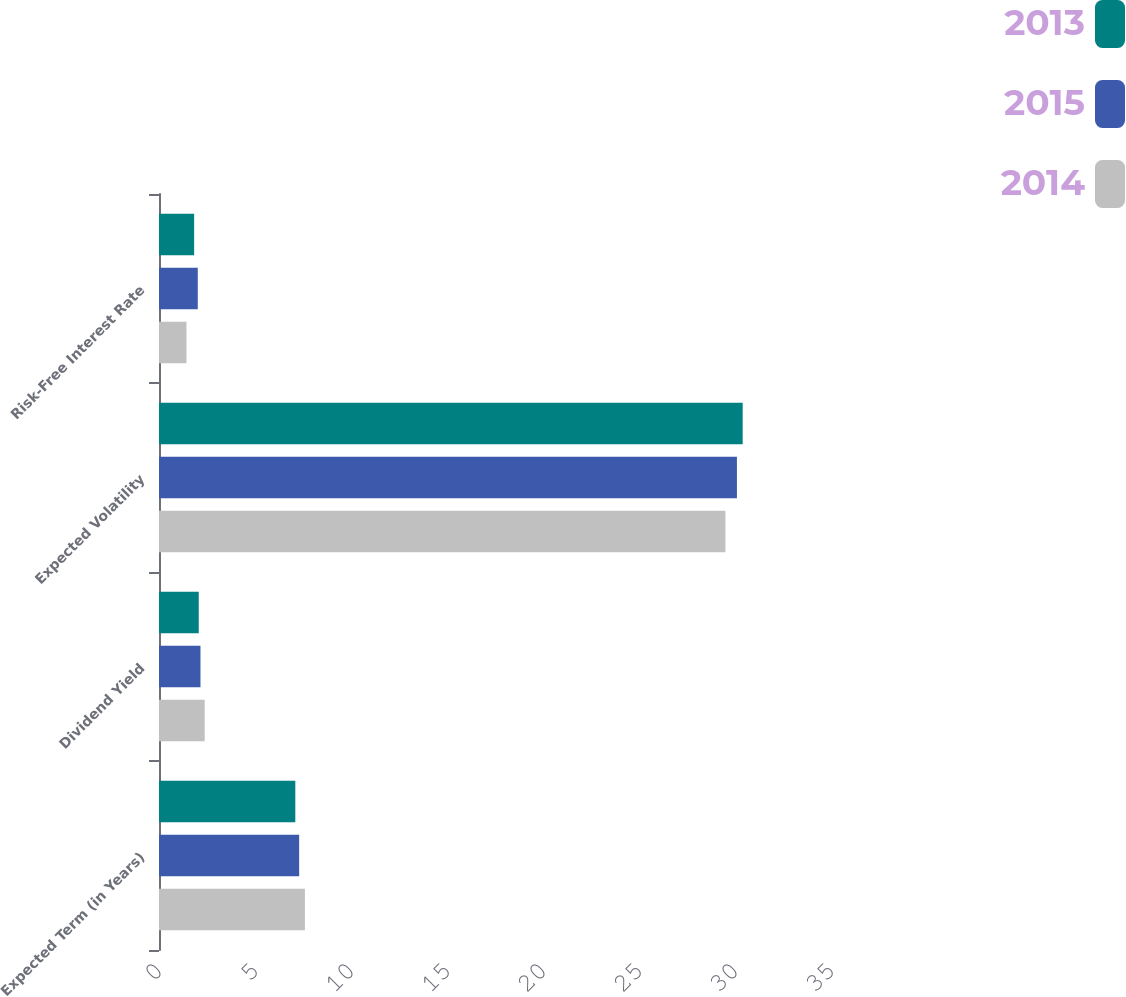Convert chart to OTSL. <chart><loc_0><loc_0><loc_500><loc_500><stacked_bar_chart><ecel><fcel>Expected Term (in Years)<fcel>Dividend Yield<fcel>Expected Volatility<fcel>Risk-Free Interest Rate<nl><fcel>2013<fcel>7.1<fcel>2.07<fcel>30.4<fcel>1.83<nl><fcel>2015<fcel>7.3<fcel>2.16<fcel>30.1<fcel>2.02<nl><fcel>2014<fcel>7.6<fcel>2.38<fcel>29.5<fcel>1.43<nl></chart> 